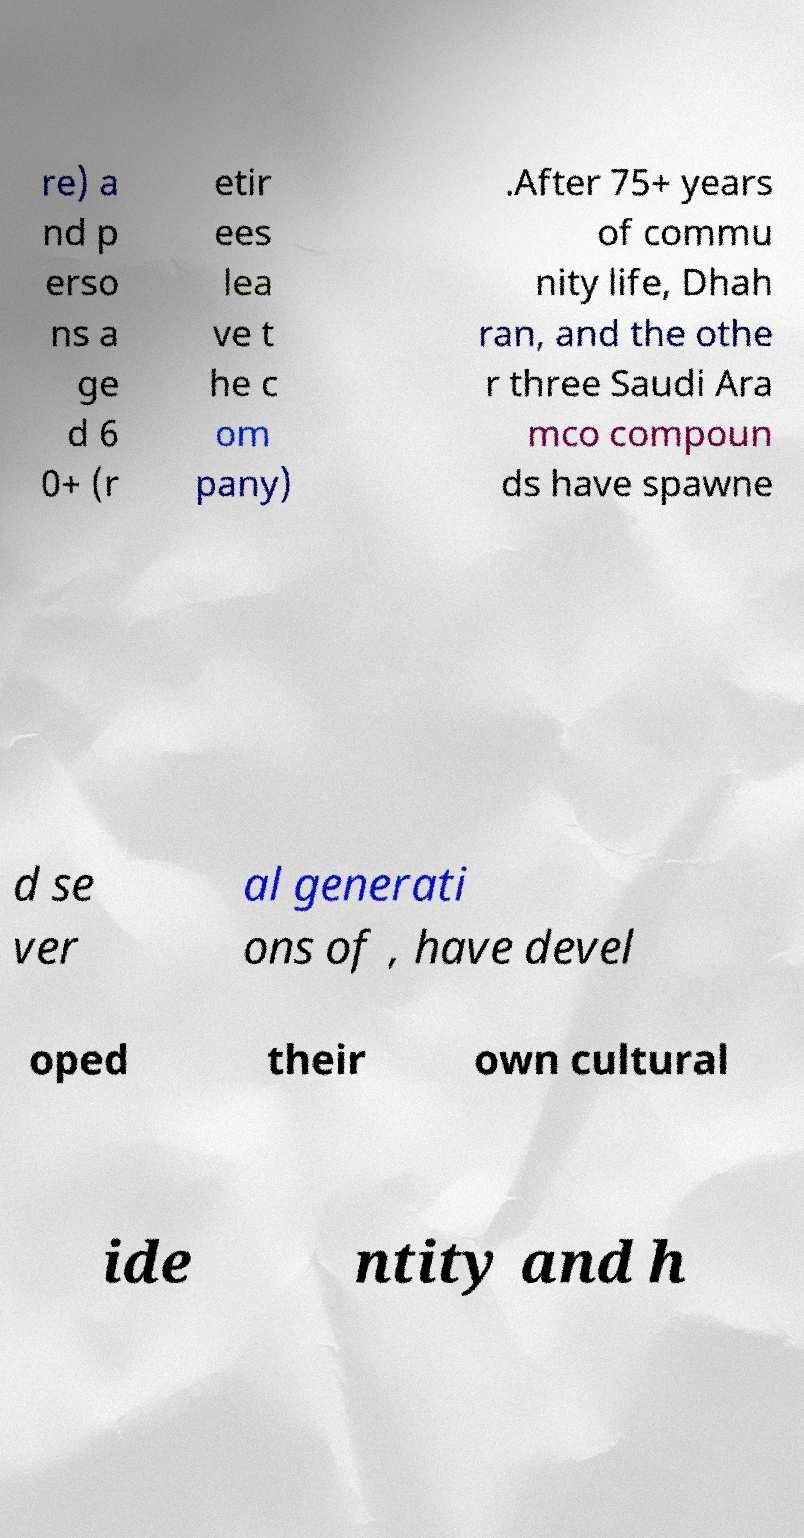Can you accurately transcribe the text from the provided image for me? re) a nd p erso ns a ge d 6 0+ (r etir ees lea ve t he c om pany) .After 75+ years of commu nity life, Dhah ran, and the othe r three Saudi Ara mco compoun ds have spawne d se ver al generati ons of , have devel oped their own cultural ide ntity and h 